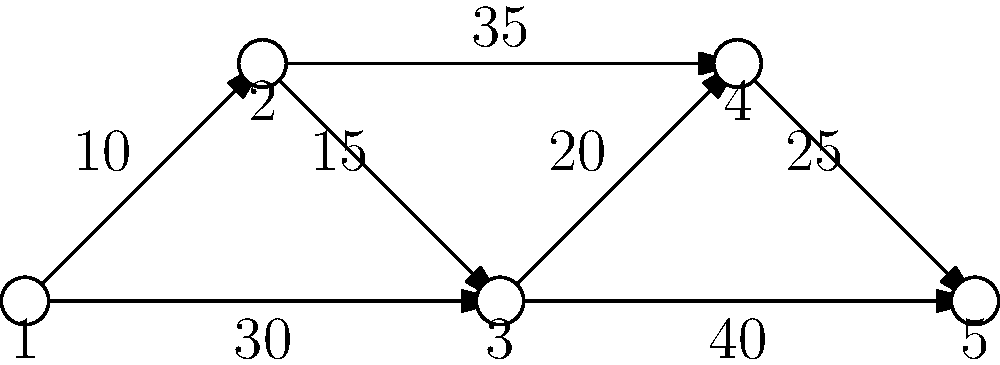Given the anonymized network graph above, where nodes represent anonymized network relays and edge weights represent the number of connections between relays, what is the maximum flow from node 1 to node 5 assuming each connection can only handle one unit of traffic? To solve this problem, we need to use the concept of maximum flow in a network. The maximum flow is limited by the minimum cut in the network. We can find this using the Ford-Fulkerson algorithm or by inspection for this simple graph. Here's the step-by-step process:

1. Identify all possible paths from node 1 to node 5:
   Path 1: 1 -> 2 -> 3 -> 4 -> 5
   Path 2: 1 -> 2 -> 3 -> 5
   Path 3: 1 -> 3 -> 4 -> 5
   Path 4: 1 -> 3 -> 5

2. Consider the edge capacities:
   Each edge can only handle one unit of traffic, regardless of the weight shown (which represents the number of connections).

3. Find the maximum flow:
   We can send one unit of flow through each of these paths without exceeding the capacity of any edge.

4. Count the number of edge-disjoint paths:
   There are 3 edge-disjoint paths from node 1 to node 5:
   - 1 -> 2 -> 3 -> 4 -> 5
   - 1 -> 3 -> 5
   - 1 -> 2 -> 3 -> 5 (sharing the 1->2 and 2->3 edges with the first path, but this is allowed as long as we don't exceed the capacity)

5. Verify the minimum cut:
   The minimum cut in this network would be the set of edges leaving node 1 (edges 1->2 and 1->3) or entering node 5 (edges 4->5 and 3->5). Both cuts have a total capacity of 3.

Therefore, the maximum flow from node 1 to node 5 is 3 units of traffic.
Answer: 3 units 